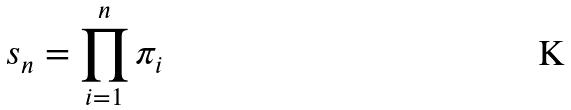<formula> <loc_0><loc_0><loc_500><loc_500>s _ { n } = \prod _ { i = 1 } ^ { n } \pi _ { i }</formula> 